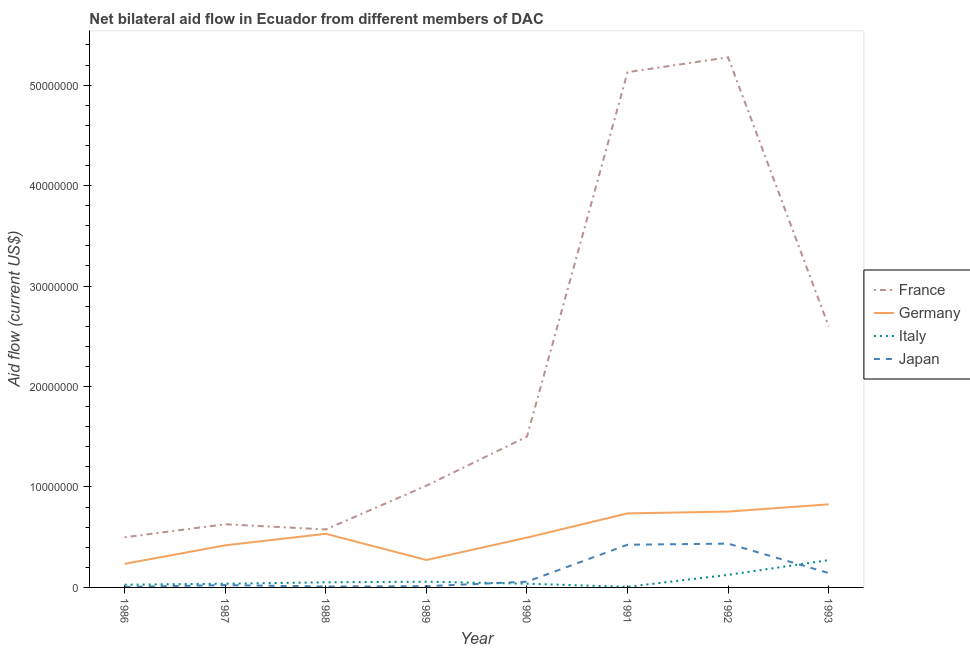How many different coloured lines are there?
Keep it short and to the point. 4. Is the number of lines equal to the number of legend labels?
Your answer should be very brief. Yes. What is the amount of aid given by italy in 1991?
Keep it short and to the point. 6.00e+04. Across all years, what is the maximum amount of aid given by japan?
Give a very brief answer. 4.36e+06. Across all years, what is the minimum amount of aid given by italy?
Provide a short and direct response. 6.00e+04. In which year was the amount of aid given by japan minimum?
Keep it short and to the point. 1986. What is the total amount of aid given by france in the graph?
Provide a succinct answer. 1.72e+08. What is the difference between the amount of aid given by japan in 1986 and that in 1989?
Keep it short and to the point. -7.00e+04. What is the difference between the amount of aid given by italy in 1992 and the amount of aid given by germany in 1988?
Make the answer very short. -4.09e+06. What is the average amount of aid given by france per year?
Your answer should be compact. 2.15e+07. In the year 1986, what is the difference between the amount of aid given by germany and amount of aid given by japan?
Offer a very short reply. 2.30e+06. In how many years, is the amount of aid given by france greater than 48000000 US$?
Provide a short and direct response. 2. What is the ratio of the amount of aid given by italy in 1989 to that in 1992?
Your answer should be compact. 0.46. Is the amount of aid given by japan in 1989 less than that in 1991?
Offer a very short reply. Yes. What is the difference between the highest and the second highest amount of aid given by france?
Give a very brief answer. 1.48e+06. What is the difference between the highest and the lowest amount of aid given by japan?
Keep it short and to the point. 4.31e+06. In how many years, is the amount of aid given by france greater than the average amount of aid given by france taken over all years?
Your answer should be compact. 3. Is the sum of the amount of aid given by italy in 1990 and 1993 greater than the maximum amount of aid given by japan across all years?
Offer a very short reply. No. Is it the case that in every year, the sum of the amount of aid given by japan and amount of aid given by germany is greater than the sum of amount of aid given by france and amount of aid given by italy?
Offer a terse response. No. Is it the case that in every year, the sum of the amount of aid given by france and amount of aid given by germany is greater than the amount of aid given by italy?
Ensure brevity in your answer.  Yes. Is the amount of aid given by japan strictly less than the amount of aid given by germany over the years?
Make the answer very short. Yes. How many lines are there?
Offer a terse response. 4. Are the values on the major ticks of Y-axis written in scientific E-notation?
Your response must be concise. No. Does the graph contain any zero values?
Ensure brevity in your answer.  No. Does the graph contain grids?
Offer a very short reply. No. Where does the legend appear in the graph?
Make the answer very short. Center right. How many legend labels are there?
Your response must be concise. 4. What is the title of the graph?
Keep it short and to the point. Net bilateral aid flow in Ecuador from different members of DAC. Does "Primary" appear as one of the legend labels in the graph?
Give a very brief answer. No. What is the label or title of the Y-axis?
Offer a very short reply. Aid flow (current US$). What is the Aid flow (current US$) in France in 1986?
Give a very brief answer. 4.99e+06. What is the Aid flow (current US$) in Germany in 1986?
Your answer should be very brief. 2.35e+06. What is the Aid flow (current US$) of France in 1987?
Offer a terse response. 6.29e+06. What is the Aid flow (current US$) of Germany in 1987?
Offer a terse response. 4.19e+06. What is the Aid flow (current US$) of France in 1988?
Offer a terse response. 5.77e+06. What is the Aid flow (current US$) of Germany in 1988?
Your answer should be very brief. 5.34e+06. What is the Aid flow (current US$) in Italy in 1988?
Provide a short and direct response. 5.10e+05. What is the Aid flow (current US$) of Japan in 1988?
Provide a succinct answer. 9.00e+04. What is the Aid flow (current US$) in France in 1989?
Offer a very short reply. 1.01e+07. What is the Aid flow (current US$) of Germany in 1989?
Ensure brevity in your answer.  2.73e+06. What is the Aid flow (current US$) in Italy in 1989?
Ensure brevity in your answer.  5.70e+05. What is the Aid flow (current US$) of Japan in 1989?
Provide a succinct answer. 1.20e+05. What is the Aid flow (current US$) of France in 1990?
Your answer should be compact. 1.50e+07. What is the Aid flow (current US$) of Germany in 1990?
Offer a terse response. 4.96e+06. What is the Aid flow (current US$) of Japan in 1990?
Your answer should be very brief. 5.70e+05. What is the Aid flow (current US$) in France in 1991?
Your answer should be very brief. 5.13e+07. What is the Aid flow (current US$) in Germany in 1991?
Your response must be concise. 7.37e+06. What is the Aid flow (current US$) in Italy in 1991?
Your response must be concise. 6.00e+04. What is the Aid flow (current US$) in Japan in 1991?
Ensure brevity in your answer.  4.25e+06. What is the Aid flow (current US$) of France in 1992?
Make the answer very short. 5.28e+07. What is the Aid flow (current US$) in Germany in 1992?
Ensure brevity in your answer.  7.55e+06. What is the Aid flow (current US$) in Italy in 1992?
Your response must be concise. 1.25e+06. What is the Aid flow (current US$) in Japan in 1992?
Your answer should be very brief. 4.36e+06. What is the Aid flow (current US$) of France in 1993?
Provide a succinct answer. 2.60e+07. What is the Aid flow (current US$) of Germany in 1993?
Ensure brevity in your answer.  8.27e+06. What is the Aid flow (current US$) of Italy in 1993?
Your answer should be very brief. 2.72e+06. What is the Aid flow (current US$) of Japan in 1993?
Give a very brief answer. 1.43e+06. Across all years, what is the maximum Aid flow (current US$) in France?
Give a very brief answer. 5.28e+07. Across all years, what is the maximum Aid flow (current US$) of Germany?
Provide a succinct answer. 8.27e+06. Across all years, what is the maximum Aid flow (current US$) of Italy?
Your answer should be very brief. 2.72e+06. Across all years, what is the maximum Aid flow (current US$) in Japan?
Your answer should be very brief. 4.36e+06. Across all years, what is the minimum Aid flow (current US$) in France?
Offer a very short reply. 4.99e+06. Across all years, what is the minimum Aid flow (current US$) in Germany?
Your response must be concise. 2.35e+06. Across all years, what is the minimum Aid flow (current US$) of Italy?
Provide a succinct answer. 6.00e+04. What is the total Aid flow (current US$) in France in the graph?
Offer a very short reply. 1.72e+08. What is the total Aid flow (current US$) of Germany in the graph?
Provide a short and direct response. 4.28e+07. What is the total Aid flow (current US$) of Italy in the graph?
Your answer should be very brief. 6.12e+06. What is the total Aid flow (current US$) of Japan in the graph?
Ensure brevity in your answer.  1.11e+07. What is the difference between the Aid flow (current US$) in France in 1986 and that in 1987?
Ensure brevity in your answer.  -1.30e+06. What is the difference between the Aid flow (current US$) of Germany in 1986 and that in 1987?
Make the answer very short. -1.84e+06. What is the difference between the Aid flow (current US$) in Italy in 1986 and that in 1987?
Make the answer very short. -1.00e+05. What is the difference between the Aid flow (current US$) of France in 1986 and that in 1988?
Ensure brevity in your answer.  -7.80e+05. What is the difference between the Aid flow (current US$) in Germany in 1986 and that in 1988?
Ensure brevity in your answer.  -2.99e+06. What is the difference between the Aid flow (current US$) of Japan in 1986 and that in 1988?
Offer a terse response. -4.00e+04. What is the difference between the Aid flow (current US$) in France in 1986 and that in 1989?
Your answer should be very brief. -5.14e+06. What is the difference between the Aid flow (current US$) in Germany in 1986 and that in 1989?
Offer a very short reply. -3.80e+05. What is the difference between the Aid flow (current US$) in Japan in 1986 and that in 1989?
Your answer should be compact. -7.00e+04. What is the difference between the Aid flow (current US$) of France in 1986 and that in 1990?
Give a very brief answer. -1.00e+07. What is the difference between the Aid flow (current US$) of Germany in 1986 and that in 1990?
Make the answer very short. -2.61e+06. What is the difference between the Aid flow (current US$) of Japan in 1986 and that in 1990?
Ensure brevity in your answer.  -5.20e+05. What is the difference between the Aid flow (current US$) of France in 1986 and that in 1991?
Your answer should be very brief. -4.63e+07. What is the difference between the Aid flow (current US$) in Germany in 1986 and that in 1991?
Keep it short and to the point. -5.02e+06. What is the difference between the Aid flow (current US$) of Italy in 1986 and that in 1991?
Give a very brief answer. 2.10e+05. What is the difference between the Aid flow (current US$) of Japan in 1986 and that in 1991?
Your answer should be compact. -4.20e+06. What is the difference between the Aid flow (current US$) in France in 1986 and that in 1992?
Your response must be concise. -4.78e+07. What is the difference between the Aid flow (current US$) of Germany in 1986 and that in 1992?
Your answer should be compact. -5.20e+06. What is the difference between the Aid flow (current US$) in Italy in 1986 and that in 1992?
Your answer should be very brief. -9.80e+05. What is the difference between the Aid flow (current US$) of Japan in 1986 and that in 1992?
Provide a succinct answer. -4.31e+06. What is the difference between the Aid flow (current US$) in France in 1986 and that in 1993?
Your answer should be very brief. -2.10e+07. What is the difference between the Aid flow (current US$) in Germany in 1986 and that in 1993?
Provide a short and direct response. -5.92e+06. What is the difference between the Aid flow (current US$) of Italy in 1986 and that in 1993?
Keep it short and to the point. -2.45e+06. What is the difference between the Aid flow (current US$) in Japan in 1986 and that in 1993?
Your answer should be very brief. -1.38e+06. What is the difference between the Aid flow (current US$) in France in 1987 and that in 1988?
Provide a succinct answer. 5.20e+05. What is the difference between the Aid flow (current US$) of Germany in 1987 and that in 1988?
Provide a succinct answer. -1.15e+06. What is the difference between the Aid flow (current US$) of Japan in 1987 and that in 1988?
Your response must be concise. 1.40e+05. What is the difference between the Aid flow (current US$) of France in 1987 and that in 1989?
Offer a very short reply. -3.84e+06. What is the difference between the Aid flow (current US$) of Germany in 1987 and that in 1989?
Provide a succinct answer. 1.46e+06. What is the difference between the Aid flow (current US$) of France in 1987 and that in 1990?
Offer a terse response. -8.72e+06. What is the difference between the Aid flow (current US$) of Germany in 1987 and that in 1990?
Your answer should be very brief. -7.70e+05. What is the difference between the Aid flow (current US$) of Italy in 1987 and that in 1990?
Your response must be concise. 0. What is the difference between the Aid flow (current US$) of Japan in 1987 and that in 1990?
Offer a very short reply. -3.40e+05. What is the difference between the Aid flow (current US$) in France in 1987 and that in 1991?
Provide a succinct answer. -4.50e+07. What is the difference between the Aid flow (current US$) in Germany in 1987 and that in 1991?
Make the answer very short. -3.18e+06. What is the difference between the Aid flow (current US$) of Italy in 1987 and that in 1991?
Provide a short and direct response. 3.10e+05. What is the difference between the Aid flow (current US$) in Japan in 1987 and that in 1991?
Give a very brief answer. -4.02e+06. What is the difference between the Aid flow (current US$) in France in 1987 and that in 1992?
Provide a short and direct response. -4.65e+07. What is the difference between the Aid flow (current US$) in Germany in 1987 and that in 1992?
Provide a short and direct response. -3.36e+06. What is the difference between the Aid flow (current US$) of Italy in 1987 and that in 1992?
Give a very brief answer. -8.80e+05. What is the difference between the Aid flow (current US$) in Japan in 1987 and that in 1992?
Your response must be concise. -4.13e+06. What is the difference between the Aid flow (current US$) in France in 1987 and that in 1993?
Offer a very short reply. -1.97e+07. What is the difference between the Aid flow (current US$) in Germany in 1987 and that in 1993?
Your answer should be very brief. -4.08e+06. What is the difference between the Aid flow (current US$) in Italy in 1987 and that in 1993?
Your answer should be very brief. -2.35e+06. What is the difference between the Aid flow (current US$) of Japan in 1987 and that in 1993?
Give a very brief answer. -1.20e+06. What is the difference between the Aid flow (current US$) in France in 1988 and that in 1989?
Your answer should be very brief. -4.36e+06. What is the difference between the Aid flow (current US$) of Germany in 1988 and that in 1989?
Offer a terse response. 2.61e+06. What is the difference between the Aid flow (current US$) in France in 1988 and that in 1990?
Your answer should be compact. -9.24e+06. What is the difference between the Aid flow (current US$) in Italy in 1988 and that in 1990?
Your answer should be compact. 1.40e+05. What is the difference between the Aid flow (current US$) in Japan in 1988 and that in 1990?
Offer a very short reply. -4.80e+05. What is the difference between the Aid flow (current US$) of France in 1988 and that in 1991?
Offer a very short reply. -4.55e+07. What is the difference between the Aid flow (current US$) in Germany in 1988 and that in 1991?
Make the answer very short. -2.03e+06. What is the difference between the Aid flow (current US$) of Japan in 1988 and that in 1991?
Make the answer very short. -4.16e+06. What is the difference between the Aid flow (current US$) of France in 1988 and that in 1992?
Your answer should be compact. -4.70e+07. What is the difference between the Aid flow (current US$) of Germany in 1988 and that in 1992?
Ensure brevity in your answer.  -2.21e+06. What is the difference between the Aid flow (current US$) in Italy in 1988 and that in 1992?
Make the answer very short. -7.40e+05. What is the difference between the Aid flow (current US$) in Japan in 1988 and that in 1992?
Offer a very short reply. -4.27e+06. What is the difference between the Aid flow (current US$) of France in 1988 and that in 1993?
Provide a succinct answer. -2.02e+07. What is the difference between the Aid flow (current US$) of Germany in 1988 and that in 1993?
Provide a succinct answer. -2.93e+06. What is the difference between the Aid flow (current US$) of Italy in 1988 and that in 1993?
Offer a very short reply. -2.21e+06. What is the difference between the Aid flow (current US$) of Japan in 1988 and that in 1993?
Give a very brief answer. -1.34e+06. What is the difference between the Aid flow (current US$) in France in 1989 and that in 1990?
Your answer should be compact. -4.88e+06. What is the difference between the Aid flow (current US$) of Germany in 1989 and that in 1990?
Offer a terse response. -2.23e+06. What is the difference between the Aid flow (current US$) of Italy in 1989 and that in 1990?
Your answer should be compact. 2.00e+05. What is the difference between the Aid flow (current US$) in Japan in 1989 and that in 1990?
Your response must be concise. -4.50e+05. What is the difference between the Aid flow (current US$) of France in 1989 and that in 1991?
Give a very brief answer. -4.12e+07. What is the difference between the Aid flow (current US$) in Germany in 1989 and that in 1991?
Offer a very short reply. -4.64e+06. What is the difference between the Aid flow (current US$) of Italy in 1989 and that in 1991?
Offer a terse response. 5.10e+05. What is the difference between the Aid flow (current US$) of Japan in 1989 and that in 1991?
Give a very brief answer. -4.13e+06. What is the difference between the Aid flow (current US$) of France in 1989 and that in 1992?
Your response must be concise. -4.26e+07. What is the difference between the Aid flow (current US$) in Germany in 1989 and that in 1992?
Offer a terse response. -4.82e+06. What is the difference between the Aid flow (current US$) of Italy in 1989 and that in 1992?
Make the answer very short. -6.80e+05. What is the difference between the Aid flow (current US$) in Japan in 1989 and that in 1992?
Your response must be concise. -4.24e+06. What is the difference between the Aid flow (current US$) in France in 1989 and that in 1993?
Offer a terse response. -1.59e+07. What is the difference between the Aid flow (current US$) in Germany in 1989 and that in 1993?
Provide a succinct answer. -5.54e+06. What is the difference between the Aid flow (current US$) of Italy in 1989 and that in 1993?
Keep it short and to the point. -2.15e+06. What is the difference between the Aid flow (current US$) of Japan in 1989 and that in 1993?
Give a very brief answer. -1.31e+06. What is the difference between the Aid flow (current US$) in France in 1990 and that in 1991?
Keep it short and to the point. -3.63e+07. What is the difference between the Aid flow (current US$) in Germany in 1990 and that in 1991?
Offer a terse response. -2.41e+06. What is the difference between the Aid flow (current US$) of Japan in 1990 and that in 1991?
Your response must be concise. -3.68e+06. What is the difference between the Aid flow (current US$) in France in 1990 and that in 1992?
Provide a succinct answer. -3.78e+07. What is the difference between the Aid flow (current US$) in Germany in 1990 and that in 1992?
Keep it short and to the point. -2.59e+06. What is the difference between the Aid flow (current US$) of Italy in 1990 and that in 1992?
Offer a terse response. -8.80e+05. What is the difference between the Aid flow (current US$) of Japan in 1990 and that in 1992?
Offer a very short reply. -3.79e+06. What is the difference between the Aid flow (current US$) in France in 1990 and that in 1993?
Give a very brief answer. -1.10e+07. What is the difference between the Aid flow (current US$) of Germany in 1990 and that in 1993?
Provide a succinct answer. -3.31e+06. What is the difference between the Aid flow (current US$) of Italy in 1990 and that in 1993?
Ensure brevity in your answer.  -2.35e+06. What is the difference between the Aid flow (current US$) of Japan in 1990 and that in 1993?
Your answer should be very brief. -8.60e+05. What is the difference between the Aid flow (current US$) in France in 1991 and that in 1992?
Offer a very short reply. -1.48e+06. What is the difference between the Aid flow (current US$) of Italy in 1991 and that in 1992?
Your answer should be very brief. -1.19e+06. What is the difference between the Aid flow (current US$) of Japan in 1991 and that in 1992?
Offer a very short reply. -1.10e+05. What is the difference between the Aid flow (current US$) in France in 1991 and that in 1993?
Give a very brief answer. 2.53e+07. What is the difference between the Aid flow (current US$) in Germany in 1991 and that in 1993?
Give a very brief answer. -9.00e+05. What is the difference between the Aid flow (current US$) in Italy in 1991 and that in 1993?
Make the answer very short. -2.66e+06. What is the difference between the Aid flow (current US$) in Japan in 1991 and that in 1993?
Provide a short and direct response. 2.82e+06. What is the difference between the Aid flow (current US$) in France in 1992 and that in 1993?
Your answer should be very brief. 2.68e+07. What is the difference between the Aid flow (current US$) in Germany in 1992 and that in 1993?
Your answer should be compact. -7.20e+05. What is the difference between the Aid flow (current US$) of Italy in 1992 and that in 1993?
Offer a very short reply. -1.47e+06. What is the difference between the Aid flow (current US$) in Japan in 1992 and that in 1993?
Provide a succinct answer. 2.93e+06. What is the difference between the Aid flow (current US$) in France in 1986 and the Aid flow (current US$) in Germany in 1987?
Offer a terse response. 8.00e+05. What is the difference between the Aid flow (current US$) of France in 1986 and the Aid flow (current US$) of Italy in 1987?
Your answer should be very brief. 4.62e+06. What is the difference between the Aid flow (current US$) of France in 1986 and the Aid flow (current US$) of Japan in 1987?
Ensure brevity in your answer.  4.76e+06. What is the difference between the Aid flow (current US$) of Germany in 1986 and the Aid flow (current US$) of Italy in 1987?
Give a very brief answer. 1.98e+06. What is the difference between the Aid flow (current US$) in Germany in 1986 and the Aid flow (current US$) in Japan in 1987?
Give a very brief answer. 2.12e+06. What is the difference between the Aid flow (current US$) of France in 1986 and the Aid flow (current US$) of Germany in 1988?
Offer a very short reply. -3.50e+05. What is the difference between the Aid flow (current US$) of France in 1986 and the Aid flow (current US$) of Italy in 1988?
Keep it short and to the point. 4.48e+06. What is the difference between the Aid flow (current US$) of France in 1986 and the Aid flow (current US$) of Japan in 1988?
Keep it short and to the point. 4.90e+06. What is the difference between the Aid flow (current US$) of Germany in 1986 and the Aid flow (current US$) of Italy in 1988?
Offer a terse response. 1.84e+06. What is the difference between the Aid flow (current US$) in Germany in 1986 and the Aid flow (current US$) in Japan in 1988?
Your response must be concise. 2.26e+06. What is the difference between the Aid flow (current US$) in France in 1986 and the Aid flow (current US$) in Germany in 1989?
Offer a terse response. 2.26e+06. What is the difference between the Aid flow (current US$) in France in 1986 and the Aid flow (current US$) in Italy in 1989?
Provide a short and direct response. 4.42e+06. What is the difference between the Aid flow (current US$) in France in 1986 and the Aid flow (current US$) in Japan in 1989?
Your answer should be compact. 4.87e+06. What is the difference between the Aid flow (current US$) in Germany in 1986 and the Aid flow (current US$) in Italy in 1989?
Give a very brief answer. 1.78e+06. What is the difference between the Aid flow (current US$) in Germany in 1986 and the Aid flow (current US$) in Japan in 1989?
Provide a succinct answer. 2.23e+06. What is the difference between the Aid flow (current US$) in Italy in 1986 and the Aid flow (current US$) in Japan in 1989?
Provide a short and direct response. 1.50e+05. What is the difference between the Aid flow (current US$) in France in 1986 and the Aid flow (current US$) in Italy in 1990?
Provide a short and direct response. 4.62e+06. What is the difference between the Aid flow (current US$) of France in 1986 and the Aid flow (current US$) of Japan in 1990?
Offer a very short reply. 4.42e+06. What is the difference between the Aid flow (current US$) in Germany in 1986 and the Aid flow (current US$) in Italy in 1990?
Offer a terse response. 1.98e+06. What is the difference between the Aid flow (current US$) in Germany in 1986 and the Aid flow (current US$) in Japan in 1990?
Provide a short and direct response. 1.78e+06. What is the difference between the Aid flow (current US$) in Italy in 1986 and the Aid flow (current US$) in Japan in 1990?
Offer a terse response. -3.00e+05. What is the difference between the Aid flow (current US$) of France in 1986 and the Aid flow (current US$) of Germany in 1991?
Your response must be concise. -2.38e+06. What is the difference between the Aid flow (current US$) of France in 1986 and the Aid flow (current US$) of Italy in 1991?
Provide a succinct answer. 4.93e+06. What is the difference between the Aid flow (current US$) of France in 1986 and the Aid flow (current US$) of Japan in 1991?
Provide a succinct answer. 7.40e+05. What is the difference between the Aid flow (current US$) of Germany in 1986 and the Aid flow (current US$) of Italy in 1991?
Keep it short and to the point. 2.29e+06. What is the difference between the Aid flow (current US$) in Germany in 1986 and the Aid flow (current US$) in Japan in 1991?
Provide a short and direct response. -1.90e+06. What is the difference between the Aid flow (current US$) in Italy in 1986 and the Aid flow (current US$) in Japan in 1991?
Your answer should be compact. -3.98e+06. What is the difference between the Aid flow (current US$) in France in 1986 and the Aid flow (current US$) in Germany in 1992?
Keep it short and to the point. -2.56e+06. What is the difference between the Aid flow (current US$) of France in 1986 and the Aid flow (current US$) of Italy in 1992?
Provide a short and direct response. 3.74e+06. What is the difference between the Aid flow (current US$) in France in 1986 and the Aid flow (current US$) in Japan in 1992?
Make the answer very short. 6.30e+05. What is the difference between the Aid flow (current US$) in Germany in 1986 and the Aid flow (current US$) in Italy in 1992?
Give a very brief answer. 1.10e+06. What is the difference between the Aid flow (current US$) of Germany in 1986 and the Aid flow (current US$) of Japan in 1992?
Ensure brevity in your answer.  -2.01e+06. What is the difference between the Aid flow (current US$) of Italy in 1986 and the Aid flow (current US$) of Japan in 1992?
Your answer should be compact. -4.09e+06. What is the difference between the Aid flow (current US$) in France in 1986 and the Aid flow (current US$) in Germany in 1993?
Make the answer very short. -3.28e+06. What is the difference between the Aid flow (current US$) in France in 1986 and the Aid flow (current US$) in Italy in 1993?
Your response must be concise. 2.27e+06. What is the difference between the Aid flow (current US$) in France in 1986 and the Aid flow (current US$) in Japan in 1993?
Your answer should be compact. 3.56e+06. What is the difference between the Aid flow (current US$) in Germany in 1986 and the Aid flow (current US$) in Italy in 1993?
Offer a very short reply. -3.70e+05. What is the difference between the Aid flow (current US$) of Germany in 1986 and the Aid flow (current US$) of Japan in 1993?
Your response must be concise. 9.20e+05. What is the difference between the Aid flow (current US$) of Italy in 1986 and the Aid flow (current US$) of Japan in 1993?
Provide a short and direct response. -1.16e+06. What is the difference between the Aid flow (current US$) in France in 1987 and the Aid flow (current US$) in Germany in 1988?
Make the answer very short. 9.50e+05. What is the difference between the Aid flow (current US$) in France in 1987 and the Aid flow (current US$) in Italy in 1988?
Offer a terse response. 5.78e+06. What is the difference between the Aid flow (current US$) of France in 1987 and the Aid flow (current US$) of Japan in 1988?
Keep it short and to the point. 6.20e+06. What is the difference between the Aid flow (current US$) of Germany in 1987 and the Aid flow (current US$) of Italy in 1988?
Provide a succinct answer. 3.68e+06. What is the difference between the Aid flow (current US$) in Germany in 1987 and the Aid flow (current US$) in Japan in 1988?
Offer a very short reply. 4.10e+06. What is the difference between the Aid flow (current US$) of Italy in 1987 and the Aid flow (current US$) of Japan in 1988?
Your answer should be very brief. 2.80e+05. What is the difference between the Aid flow (current US$) of France in 1987 and the Aid flow (current US$) of Germany in 1989?
Offer a terse response. 3.56e+06. What is the difference between the Aid flow (current US$) of France in 1987 and the Aid flow (current US$) of Italy in 1989?
Provide a short and direct response. 5.72e+06. What is the difference between the Aid flow (current US$) of France in 1987 and the Aid flow (current US$) of Japan in 1989?
Offer a very short reply. 6.17e+06. What is the difference between the Aid flow (current US$) of Germany in 1987 and the Aid flow (current US$) of Italy in 1989?
Make the answer very short. 3.62e+06. What is the difference between the Aid flow (current US$) of Germany in 1987 and the Aid flow (current US$) of Japan in 1989?
Ensure brevity in your answer.  4.07e+06. What is the difference between the Aid flow (current US$) of France in 1987 and the Aid flow (current US$) of Germany in 1990?
Keep it short and to the point. 1.33e+06. What is the difference between the Aid flow (current US$) of France in 1987 and the Aid flow (current US$) of Italy in 1990?
Offer a very short reply. 5.92e+06. What is the difference between the Aid flow (current US$) of France in 1987 and the Aid flow (current US$) of Japan in 1990?
Give a very brief answer. 5.72e+06. What is the difference between the Aid flow (current US$) of Germany in 1987 and the Aid flow (current US$) of Italy in 1990?
Provide a short and direct response. 3.82e+06. What is the difference between the Aid flow (current US$) in Germany in 1987 and the Aid flow (current US$) in Japan in 1990?
Your response must be concise. 3.62e+06. What is the difference between the Aid flow (current US$) in Italy in 1987 and the Aid flow (current US$) in Japan in 1990?
Your answer should be compact. -2.00e+05. What is the difference between the Aid flow (current US$) in France in 1987 and the Aid flow (current US$) in Germany in 1991?
Make the answer very short. -1.08e+06. What is the difference between the Aid flow (current US$) of France in 1987 and the Aid flow (current US$) of Italy in 1991?
Offer a terse response. 6.23e+06. What is the difference between the Aid flow (current US$) of France in 1987 and the Aid flow (current US$) of Japan in 1991?
Offer a terse response. 2.04e+06. What is the difference between the Aid flow (current US$) in Germany in 1987 and the Aid flow (current US$) in Italy in 1991?
Provide a succinct answer. 4.13e+06. What is the difference between the Aid flow (current US$) of Germany in 1987 and the Aid flow (current US$) of Japan in 1991?
Keep it short and to the point. -6.00e+04. What is the difference between the Aid flow (current US$) of Italy in 1987 and the Aid flow (current US$) of Japan in 1991?
Your answer should be very brief. -3.88e+06. What is the difference between the Aid flow (current US$) in France in 1987 and the Aid flow (current US$) in Germany in 1992?
Give a very brief answer. -1.26e+06. What is the difference between the Aid flow (current US$) in France in 1987 and the Aid flow (current US$) in Italy in 1992?
Offer a terse response. 5.04e+06. What is the difference between the Aid flow (current US$) of France in 1987 and the Aid flow (current US$) of Japan in 1992?
Ensure brevity in your answer.  1.93e+06. What is the difference between the Aid flow (current US$) in Germany in 1987 and the Aid flow (current US$) in Italy in 1992?
Ensure brevity in your answer.  2.94e+06. What is the difference between the Aid flow (current US$) in Germany in 1987 and the Aid flow (current US$) in Japan in 1992?
Your response must be concise. -1.70e+05. What is the difference between the Aid flow (current US$) in Italy in 1987 and the Aid flow (current US$) in Japan in 1992?
Make the answer very short. -3.99e+06. What is the difference between the Aid flow (current US$) in France in 1987 and the Aid flow (current US$) in Germany in 1993?
Offer a very short reply. -1.98e+06. What is the difference between the Aid flow (current US$) of France in 1987 and the Aid flow (current US$) of Italy in 1993?
Your response must be concise. 3.57e+06. What is the difference between the Aid flow (current US$) of France in 1987 and the Aid flow (current US$) of Japan in 1993?
Your answer should be very brief. 4.86e+06. What is the difference between the Aid flow (current US$) of Germany in 1987 and the Aid flow (current US$) of Italy in 1993?
Provide a succinct answer. 1.47e+06. What is the difference between the Aid flow (current US$) in Germany in 1987 and the Aid flow (current US$) in Japan in 1993?
Offer a very short reply. 2.76e+06. What is the difference between the Aid flow (current US$) of Italy in 1987 and the Aid flow (current US$) of Japan in 1993?
Ensure brevity in your answer.  -1.06e+06. What is the difference between the Aid flow (current US$) in France in 1988 and the Aid flow (current US$) in Germany in 1989?
Keep it short and to the point. 3.04e+06. What is the difference between the Aid flow (current US$) in France in 1988 and the Aid flow (current US$) in Italy in 1989?
Ensure brevity in your answer.  5.20e+06. What is the difference between the Aid flow (current US$) in France in 1988 and the Aid flow (current US$) in Japan in 1989?
Offer a very short reply. 5.65e+06. What is the difference between the Aid flow (current US$) of Germany in 1988 and the Aid flow (current US$) of Italy in 1989?
Your answer should be compact. 4.77e+06. What is the difference between the Aid flow (current US$) in Germany in 1988 and the Aid flow (current US$) in Japan in 1989?
Your response must be concise. 5.22e+06. What is the difference between the Aid flow (current US$) in Italy in 1988 and the Aid flow (current US$) in Japan in 1989?
Make the answer very short. 3.90e+05. What is the difference between the Aid flow (current US$) of France in 1988 and the Aid flow (current US$) of Germany in 1990?
Keep it short and to the point. 8.10e+05. What is the difference between the Aid flow (current US$) in France in 1988 and the Aid flow (current US$) in Italy in 1990?
Provide a succinct answer. 5.40e+06. What is the difference between the Aid flow (current US$) of France in 1988 and the Aid flow (current US$) of Japan in 1990?
Make the answer very short. 5.20e+06. What is the difference between the Aid flow (current US$) of Germany in 1988 and the Aid flow (current US$) of Italy in 1990?
Offer a terse response. 4.97e+06. What is the difference between the Aid flow (current US$) of Germany in 1988 and the Aid flow (current US$) of Japan in 1990?
Ensure brevity in your answer.  4.77e+06. What is the difference between the Aid flow (current US$) in France in 1988 and the Aid flow (current US$) in Germany in 1991?
Make the answer very short. -1.60e+06. What is the difference between the Aid flow (current US$) of France in 1988 and the Aid flow (current US$) of Italy in 1991?
Keep it short and to the point. 5.71e+06. What is the difference between the Aid flow (current US$) in France in 1988 and the Aid flow (current US$) in Japan in 1991?
Give a very brief answer. 1.52e+06. What is the difference between the Aid flow (current US$) of Germany in 1988 and the Aid flow (current US$) of Italy in 1991?
Provide a succinct answer. 5.28e+06. What is the difference between the Aid flow (current US$) of Germany in 1988 and the Aid flow (current US$) of Japan in 1991?
Provide a short and direct response. 1.09e+06. What is the difference between the Aid flow (current US$) in Italy in 1988 and the Aid flow (current US$) in Japan in 1991?
Provide a succinct answer. -3.74e+06. What is the difference between the Aid flow (current US$) of France in 1988 and the Aid flow (current US$) of Germany in 1992?
Provide a succinct answer. -1.78e+06. What is the difference between the Aid flow (current US$) of France in 1988 and the Aid flow (current US$) of Italy in 1992?
Ensure brevity in your answer.  4.52e+06. What is the difference between the Aid flow (current US$) in France in 1988 and the Aid flow (current US$) in Japan in 1992?
Provide a succinct answer. 1.41e+06. What is the difference between the Aid flow (current US$) of Germany in 1988 and the Aid flow (current US$) of Italy in 1992?
Make the answer very short. 4.09e+06. What is the difference between the Aid flow (current US$) in Germany in 1988 and the Aid flow (current US$) in Japan in 1992?
Give a very brief answer. 9.80e+05. What is the difference between the Aid flow (current US$) in Italy in 1988 and the Aid flow (current US$) in Japan in 1992?
Your answer should be very brief. -3.85e+06. What is the difference between the Aid flow (current US$) in France in 1988 and the Aid flow (current US$) in Germany in 1993?
Ensure brevity in your answer.  -2.50e+06. What is the difference between the Aid flow (current US$) of France in 1988 and the Aid flow (current US$) of Italy in 1993?
Your answer should be very brief. 3.05e+06. What is the difference between the Aid flow (current US$) in France in 1988 and the Aid flow (current US$) in Japan in 1993?
Ensure brevity in your answer.  4.34e+06. What is the difference between the Aid flow (current US$) in Germany in 1988 and the Aid flow (current US$) in Italy in 1993?
Ensure brevity in your answer.  2.62e+06. What is the difference between the Aid flow (current US$) in Germany in 1988 and the Aid flow (current US$) in Japan in 1993?
Give a very brief answer. 3.91e+06. What is the difference between the Aid flow (current US$) in Italy in 1988 and the Aid flow (current US$) in Japan in 1993?
Provide a short and direct response. -9.20e+05. What is the difference between the Aid flow (current US$) of France in 1989 and the Aid flow (current US$) of Germany in 1990?
Your answer should be very brief. 5.17e+06. What is the difference between the Aid flow (current US$) of France in 1989 and the Aid flow (current US$) of Italy in 1990?
Ensure brevity in your answer.  9.76e+06. What is the difference between the Aid flow (current US$) in France in 1989 and the Aid flow (current US$) in Japan in 1990?
Offer a terse response. 9.56e+06. What is the difference between the Aid flow (current US$) in Germany in 1989 and the Aid flow (current US$) in Italy in 1990?
Your response must be concise. 2.36e+06. What is the difference between the Aid flow (current US$) of Germany in 1989 and the Aid flow (current US$) of Japan in 1990?
Provide a succinct answer. 2.16e+06. What is the difference between the Aid flow (current US$) of Italy in 1989 and the Aid flow (current US$) of Japan in 1990?
Keep it short and to the point. 0. What is the difference between the Aid flow (current US$) in France in 1989 and the Aid flow (current US$) in Germany in 1991?
Your response must be concise. 2.76e+06. What is the difference between the Aid flow (current US$) in France in 1989 and the Aid flow (current US$) in Italy in 1991?
Provide a succinct answer. 1.01e+07. What is the difference between the Aid flow (current US$) of France in 1989 and the Aid flow (current US$) of Japan in 1991?
Ensure brevity in your answer.  5.88e+06. What is the difference between the Aid flow (current US$) of Germany in 1989 and the Aid flow (current US$) of Italy in 1991?
Make the answer very short. 2.67e+06. What is the difference between the Aid flow (current US$) of Germany in 1989 and the Aid flow (current US$) of Japan in 1991?
Offer a very short reply. -1.52e+06. What is the difference between the Aid flow (current US$) in Italy in 1989 and the Aid flow (current US$) in Japan in 1991?
Provide a succinct answer. -3.68e+06. What is the difference between the Aid flow (current US$) in France in 1989 and the Aid flow (current US$) in Germany in 1992?
Offer a terse response. 2.58e+06. What is the difference between the Aid flow (current US$) of France in 1989 and the Aid flow (current US$) of Italy in 1992?
Provide a short and direct response. 8.88e+06. What is the difference between the Aid flow (current US$) of France in 1989 and the Aid flow (current US$) of Japan in 1992?
Offer a terse response. 5.77e+06. What is the difference between the Aid flow (current US$) in Germany in 1989 and the Aid flow (current US$) in Italy in 1992?
Ensure brevity in your answer.  1.48e+06. What is the difference between the Aid flow (current US$) in Germany in 1989 and the Aid flow (current US$) in Japan in 1992?
Your response must be concise. -1.63e+06. What is the difference between the Aid flow (current US$) of Italy in 1989 and the Aid flow (current US$) of Japan in 1992?
Offer a very short reply. -3.79e+06. What is the difference between the Aid flow (current US$) in France in 1989 and the Aid flow (current US$) in Germany in 1993?
Provide a short and direct response. 1.86e+06. What is the difference between the Aid flow (current US$) in France in 1989 and the Aid flow (current US$) in Italy in 1993?
Offer a very short reply. 7.41e+06. What is the difference between the Aid flow (current US$) in France in 1989 and the Aid flow (current US$) in Japan in 1993?
Provide a short and direct response. 8.70e+06. What is the difference between the Aid flow (current US$) in Germany in 1989 and the Aid flow (current US$) in Japan in 1993?
Your response must be concise. 1.30e+06. What is the difference between the Aid flow (current US$) in Italy in 1989 and the Aid flow (current US$) in Japan in 1993?
Make the answer very short. -8.60e+05. What is the difference between the Aid flow (current US$) of France in 1990 and the Aid flow (current US$) of Germany in 1991?
Make the answer very short. 7.64e+06. What is the difference between the Aid flow (current US$) of France in 1990 and the Aid flow (current US$) of Italy in 1991?
Ensure brevity in your answer.  1.50e+07. What is the difference between the Aid flow (current US$) of France in 1990 and the Aid flow (current US$) of Japan in 1991?
Give a very brief answer. 1.08e+07. What is the difference between the Aid flow (current US$) of Germany in 1990 and the Aid flow (current US$) of Italy in 1991?
Provide a succinct answer. 4.90e+06. What is the difference between the Aid flow (current US$) in Germany in 1990 and the Aid flow (current US$) in Japan in 1991?
Provide a succinct answer. 7.10e+05. What is the difference between the Aid flow (current US$) of Italy in 1990 and the Aid flow (current US$) of Japan in 1991?
Provide a succinct answer. -3.88e+06. What is the difference between the Aid flow (current US$) in France in 1990 and the Aid flow (current US$) in Germany in 1992?
Give a very brief answer. 7.46e+06. What is the difference between the Aid flow (current US$) in France in 1990 and the Aid flow (current US$) in Italy in 1992?
Your answer should be very brief. 1.38e+07. What is the difference between the Aid flow (current US$) in France in 1990 and the Aid flow (current US$) in Japan in 1992?
Offer a terse response. 1.06e+07. What is the difference between the Aid flow (current US$) of Germany in 1990 and the Aid flow (current US$) of Italy in 1992?
Your response must be concise. 3.71e+06. What is the difference between the Aid flow (current US$) of Germany in 1990 and the Aid flow (current US$) of Japan in 1992?
Your response must be concise. 6.00e+05. What is the difference between the Aid flow (current US$) in Italy in 1990 and the Aid flow (current US$) in Japan in 1992?
Make the answer very short. -3.99e+06. What is the difference between the Aid flow (current US$) of France in 1990 and the Aid flow (current US$) of Germany in 1993?
Offer a very short reply. 6.74e+06. What is the difference between the Aid flow (current US$) of France in 1990 and the Aid flow (current US$) of Italy in 1993?
Offer a very short reply. 1.23e+07. What is the difference between the Aid flow (current US$) in France in 1990 and the Aid flow (current US$) in Japan in 1993?
Offer a terse response. 1.36e+07. What is the difference between the Aid flow (current US$) of Germany in 1990 and the Aid flow (current US$) of Italy in 1993?
Ensure brevity in your answer.  2.24e+06. What is the difference between the Aid flow (current US$) of Germany in 1990 and the Aid flow (current US$) of Japan in 1993?
Offer a terse response. 3.53e+06. What is the difference between the Aid flow (current US$) in Italy in 1990 and the Aid flow (current US$) in Japan in 1993?
Ensure brevity in your answer.  -1.06e+06. What is the difference between the Aid flow (current US$) of France in 1991 and the Aid flow (current US$) of Germany in 1992?
Your response must be concise. 4.37e+07. What is the difference between the Aid flow (current US$) in France in 1991 and the Aid flow (current US$) in Italy in 1992?
Ensure brevity in your answer.  5.00e+07. What is the difference between the Aid flow (current US$) of France in 1991 and the Aid flow (current US$) of Japan in 1992?
Ensure brevity in your answer.  4.69e+07. What is the difference between the Aid flow (current US$) in Germany in 1991 and the Aid flow (current US$) in Italy in 1992?
Keep it short and to the point. 6.12e+06. What is the difference between the Aid flow (current US$) in Germany in 1991 and the Aid flow (current US$) in Japan in 1992?
Your answer should be very brief. 3.01e+06. What is the difference between the Aid flow (current US$) of Italy in 1991 and the Aid flow (current US$) of Japan in 1992?
Your answer should be compact. -4.30e+06. What is the difference between the Aid flow (current US$) of France in 1991 and the Aid flow (current US$) of Germany in 1993?
Ensure brevity in your answer.  4.30e+07. What is the difference between the Aid flow (current US$) in France in 1991 and the Aid flow (current US$) in Italy in 1993?
Make the answer very short. 4.86e+07. What is the difference between the Aid flow (current US$) in France in 1991 and the Aid flow (current US$) in Japan in 1993?
Offer a very short reply. 4.99e+07. What is the difference between the Aid flow (current US$) of Germany in 1991 and the Aid flow (current US$) of Italy in 1993?
Your response must be concise. 4.65e+06. What is the difference between the Aid flow (current US$) in Germany in 1991 and the Aid flow (current US$) in Japan in 1993?
Your answer should be very brief. 5.94e+06. What is the difference between the Aid flow (current US$) of Italy in 1991 and the Aid flow (current US$) of Japan in 1993?
Your answer should be very brief. -1.37e+06. What is the difference between the Aid flow (current US$) of France in 1992 and the Aid flow (current US$) of Germany in 1993?
Give a very brief answer. 4.45e+07. What is the difference between the Aid flow (current US$) of France in 1992 and the Aid flow (current US$) of Italy in 1993?
Offer a terse response. 5.00e+07. What is the difference between the Aid flow (current US$) in France in 1992 and the Aid flow (current US$) in Japan in 1993?
Offer a terse response. 5.13e+07. What is the difference between the Aid flow (current US$) in Germany in 1992 and the Aid flow (current US$) in Italy in 1993?
Ensure brevity in your answer.  4.83e+06. What is the difference between the Aid flow (current US$) of Germany in 1992 and the Aid flow (current US$) of Japan in 1993?
Provide a short and direct response. 6.12e+06. What is the difference between the Aid flow (current US$) in Italy in 1992 and the Aid flow (current US$) in Japan in 1993?
Your answer should be very brief. -1.80e+05. What is the average Aid flow (current US$) of France per year?
Provide a short and direct response. 2.15e+07. What is the average Aid flow (current US$) in Germany per year?
Your answer should be compact. 5.34e+06. What is the average Aid flow (current US$) in Italy per year?
Offer a very short reply. 7.65e+05. What is the average Aid flow (current US$) in Japan per year?
Ensure brevity in your answer.  1.39e+06. In the year 1986, what is the difference between the Aid flow (current US$) of France and Aid flow (current US$) of Germany?
Your answer should be very brief. 2.64e+06. In the year 1986, what is the difference between the Aid flow (current US$) of France and Aid flow (current US$) of Italy?
Give a very brief answer. 4.72e+06. In the year 1986, what is the difference between the Aid flow (current US$) in France and Aid flow (current US$) in Japan?
Your answer should be compact. 4.94e+06. In the year 1986, what is the difference between the Aid flow (current US$) of Germany and Aid flow (current US$) of Italy?
Provide a short and direct response. 2.08e+06. In the year 1986, what is the difference between the Aid flow (current US$) in Germany and Aid flow (current US$) in Japan?
Provide a short and direct response. 2.30e+06. In the year 1987, what is the difference between the Aid flow (current US$) in France and Aid flow (current US$) in Germany?
Provide a succinct answer. 2.10e+06. In the year 1987, what is the difference between the Aid flow (current US$) of France and Aid flow (current US$) of Italy?
Keep it short and to the point. 5.92e+06. In the year 1987, what is the difference between the Aid flow (current US$) in France and Aid flow (current US$) in Japan?
Ensure brevity in your answer.  6.06e+06. In the year 1987, what is the difference between the Aid flow (current US$) of Germany and Aid flow (current US$) of Italy?
Your response must be concise. 3.82e+06. In the year 1987, what is the difference between the Aid flow (current US$) of Germany and Aid flow (current US$) of Japan?
Make the answer very short. 3.96e+06. In the year 1988, what is the difference between the Aid flow (current US$) of France and Aid flow (current US$) of Italy?
Offer a very short reply. 5.26e+06. In the year 1988, what is the difference between the Aid flow (current US$) in France and Aid flow (current US$) in Japan?
Your answer should be compact. 5.68e+06. In the year 1988, what is the difference between the Aid flow (current US$) of Germany and Aid flow (current US$) of Italy?
Offer a terse response. 4.83e+06. In the year 1988, what is the difference between the Aid flow (current US$) of Germany and Aid flow (current US$) of Japan?
Offer a very short reply. 5.25e+06. In the year 1989, what is the difference between the Aid flow (current US$) of France and Aid flow (current US$) of Germany?
Provide a short and direct response. 7.40e+06. In the year 1989, what is the difference between the Aid flow (current US$) in France and Aid flow (current US$) in Italy?
Offer a very short reply. 9.56e+06. In the year 1989, what is the difference between the Aid flow (current US$) in France and Aid flow (current US$) in Japan?
Your answer should be compact. 1.00e+07. In the year 1989, what is the difference between the Aid flow (current US$) in Germany and Aid flow (current US$) in Italy?
Provide a short and direct response. 2.16e+06. In the year 1989, what is the difference between the Aid flow (current US$) in Germany and Aid flow (current US$) in Japan?
Provide a short and direct response. 2.61e+06. In the year 1990, what is the difference between the Aid flow (current US$) of France and Aid flow (current US$) of Germany?
Provide a short and direct response. 1.00e+07. In the year 1990, what is the difference between the Aid flow (current US$) in France and Aid flow (current US$) in Italy?
Offer a very short reply. 1.46e+07. In the year 1990, what is the difference between the Aid flow (current US$) of France and Aid flow (current US$) of Japan?
Offer a very short reply. 1.44e+07. In the year 1990, what is the difference between the Aid flow (current US$) of Germany and Aid flow (current US$) of Italy?
Ensure brevity in your answer.  4.59e+06. In the year 1990, what is the difference between the Aid flow (current US$) in Germany and Aid flow (current US$) in Japan?
Provide a short and direct response. 4.39e+06. In the year 1991, what is the difference between the Aid flow (current US$) of France and Aid flow (current US$) of Germany?
Your answer should be very brief. 4.39e+07. In the year 1991, what is the difference between the Aid flow (current US$) in France and Aid flow (current US$) in Italy?
Ensure brevity in your answer.  5.12e+07. In the year 1991, what is the difference between the Aid flow (current US$) of France and Aid flow (current US$) of Japan?
Offer a terse response. 4.70e+07. In the year 1991, what is the difference between the Aid flow (current US$) in Germany and Aid flow (current US$) in Italy?
Keep it short and to the point. 7.31e+06. In the year 1991, what is the difference between the Aid flow (current US$) in Germany and Aid flow (current US$) in Japan?
Offer a terse response. 3.12e+06. In the year 1991, what is the difference between the Aid flow (current US$) of Italy and Aid flow (current US$) of Japan?
Provide a short and direct response. -4.19e+06. In the year 1992, what is the difference between the Aid flow (current US$) of France and Aid flow (current US$) of Germany?
Offer a terse response. 4.52e+07. In the year 1992, what is the difference between the Aid flow (current US$) in France and Aid flow (current US$) in Italy?
Ensure brevity in your answer.  5.15e+07. In the year 1992, what is the difference between the Aid flow (current US$) in France and Aid flow (current US$) in Japan?
Give a very brief answer. 4.84e+07. In the year 1992, what is the difference between the Aid flow (current US$) of Germany and Aid flow (current US$) of Italy?
Ensure brevity in your answer.  6.30e+06. In the year 1992, what is the difference between the Aid flow (current US$) in Germany and Aid flow (current US$) in Japan?
Offer a very short reply. 3.19e+06. In the year 1992, what is the difference between the Aid flow (current US$) in Italy and Aid flow (current US$) in Japan?
Offer a very short reply. -3.11e+06. In the year 1993, what is the difference between the Aid flow (current US$) of France and Aid flow (current US$) of Germany?
Provide a short and direct response. 1.77e+07. In the year 1993, what is the difference between the Aid flow (current US$) in France and Aid flow (current US$) in Italy?
Offer a terse response. 2.33e+07. In the year 1993, what is the difference between the Aid flow (current US$) of France and Aid flow (current US$) of Japan?
Provide a succinct answer. 2.46e+07. In the year 1993, what is the difference between the Aid flow (current US$) of Germany and Aid flow (current US$) of Italy?
Ensure brevity in your answer.  5.55e+06. In the year 1993, what is the difference between the Aid flow (current US$) of Germany and Aid flow (current US$) of Japan?
Provide a succinct answer. 6.84e+06. In the year 1993, what is the difference between the Aid flow (current US$) of Italy and Aid flow (current US$) of Japan?
Ensure brevity in your answer.  1.29e+06. What is the ratio of the Aid flow (current US$) in France in 1986 to that in 1987?
Ensure brevity in your answer.  0.79. What is the ratio of the Aid flow (current US$) in Germany in 1986 to that in 1987?
Provide a succinct answer. 0.56. What is the ratio of the Aid flow (current US$) in Italy in 1986 to that in 1987?
Provide a succinct answer. 0.73. What is the ratio of the Aid flow (current US$) in Japan in 1986 to that in 1987?
Ensure brevity in your answer.  0.22. What is the ratio of the Aid flow (current US$) in France in 1986 to that in 1988?
Offer a very short reply. 0.86. What is the ratio of the Aid flow (current US$) in Germany in 1986 to that in 1988?
Offer a terse response. 0.44. What is the ratio of the Aid flow (current US$) in Italy in 1986 to that in 1988?
Offer a terse response. 0.53. What is the ratio of the Aid flow (current US$) in Japan in 1986 to that in 1988?
Make the answer very short. 0.56. What is the ratio of the Aid flow (current US$) in France in 1986 to that in 1989?
Give a very brief answer. 0.49. What is the ratio of the Aid flow (current US$) of Germany in 1986 to that in 1989?
Provide a short and direct response. 0.86. What is the ratio of the Aid flow (current US$) in Italy in 1986 to that in 1989?
Provide a short and direct response. 0.47. What is the ratio of the Aid flow (current US$) in Japan in 1986 to that in 1989?
Your answer should be very brief. 0.42. What is the ratio of the Aid flow (current US$) in France in 1986 to that in 1990?
Offer a terse response. 0.33. What is the ratio of the Aid flow (current US$) in Germany in 1986 to that in 1990?
Your answer should be very brief. 0.47. What is the ratio of the Aid flow (current US$) in Italy in 1986 to that in 1990?
Your answer should be very brief. 0.73. What is the ratio of the Aid flow (current US$) of Japan in 1986 to that in 1990?
Your response must be concise. 0.09. What is the ratio of the Aid flow (current US$) in France in 1986 to that in 1991?
Your response must be concise. 0.1. What is the ratio of the Aid flow (current US$) in Germany in 1986 to that in 1991?
Your answer should be compact. 0.32. What is the ratio of the Aid flow (current US$) in Japan in 1986 to that in 1991?
Keep it short and to the point. 0.01. What is the ratio of the Aid flow (current US$) of France in 1986 to that in 1992?
Offer a terse response. 0.09. What is the ratio of the Aid flow (current US$) in Germany in 1986 to that in 1992?
Your response must be concise. 0.31. What is the ratio of the Aid flow (current US$) of Italy in 1986 to that in 1992?
Offer a very short reply. 0.22. What is the ratio of the Aid flow (current US$) of Japan in 1986 to that in 1992?
Your answer should be very brief. 0.01. What is the ratio of the Aid flow (current US$) of France in 1986 to that in 1993?
Your answer should be compact. 0.19. What is the ratio of the Aid flow (current US$) of Germany in 1986 to that in 1993?
Give a very brief answer. 0.28. What is the ratio of the Aid flow (current US$) in Italy in 1986 to that in 1993?
Your answer should be very brief. 0.1. What is the ratio of the Aid flow (current US$) of Japan in 1986 to that in 1993?
Provide a short and direct response. 0.04. What is the ratio of the Aid flow (current US$) of France in 1987 to that in 1988?
Ensure brevity in your answer.  1.09. What is the ratio of the Aid flow (current US$) of Germany in 1987 to that in 1988?
Make the answer very short. 0.78. What is the ratio of the Aid flow (current US$) in Italy in 1987 to that in 1988?
Provide a succinct answer. 0.73. What is the ratio of the Aid flow (current US$) of Japan in 1987 to that in 1988?
Offer a very short reply. 2.56. What is the ratio of the Aid flow (current US$) in France in 1987 to that in 1989?
Offer a terse response. 0.62. What is the ratio of the Aid flow (current US$) of Germany in 1987 to that in 1989?
Offer a very short reply. 1.53. What is the ratio of the Aid flow (current US$) in Italy in 1987 to that in 1989?
Offer a terse response. 0.65. What is the ratio of the Aid flow (current US$) of Japan in 1987 to that in 1989?
Your answer should be compact. 1.92. What is the ratio of the Aid flow (current US$) of France in 1987 to that in 1990?
Make the answer very short. 0.42. What is the ratio of the Aid flow (current US$) in Germany in 1987 to that in 1990?
Provide a succinct answer. 0.84. What is the ratio of the Aid flow (current US$) of Italy in 1987 to that in 1990?
Keep it short and to the point. 1. What is the ratio of the Aid flow (current US$) of Japan in 1987 to that in 1990?
Your answer should be compact. 0.4. What is the ratio of the Aid flow (current US$) of France in 1987 to that in 1991?
Make the answer very short. 0.12. What is the ratio of the Aid flow (current US$) in Germany in 1987 to that in 1991?
Offer a terse response. 0.57. What is the ratio of the Aid flow (current US$) of Italy in 1987 to that in 1991?
Your response must be concise. 6.17. What is the ratio of the Aid flow (current US$) in Japan in 1987 to that in 1991?
Provide a short and direct response. 0.05. What is the ratio of the Aid flow (current US$) in France in 1987 to that in 1992?
Provide a short and direct response. 0.12. What is the ratio of the Aid flow (current US$) of Germany in 1987 to that in 1992?
Offer a very short reply. 0.56. What is the ratio of the Aid flow (current US$) in Italy in 1987 to that in 1992?
Your response must be concise. 0.3. What is the ratio of the Aid flow (current US$) in Japan in 1987 to that in 1992?
Your answer should be compact. 0.05. What is the ratio of the Aid flow (current US$) of France in 1987 to that in 1993?
Provide a succinct answer. 0.24. What is the ratio of the Aid flow (current US$) of Germany in 1987 to that in 1993?
Your answer should be compact. 0.51. What is the ratio of the Aid flow (current US$) in Italy in 1987 to that in 1993?
Offer a terse response. 0.14. What is the ratio of the Aid flow (current US$) in Japan in 1987 to that in 1993?
Offer a very short reply. 0.16. What is the ratio of the Aid flow (current US$) of France in 1988 to that in 1989?
Offer a very short reply. 0.57. What is the ratio of the Aid flow (current US$) in Germany in 1988 to that in 1989?
Offer a very short reply. 1.96. What is the ratio of the Aid flow (current US$) in Italy in 1988 to that in 1989?
Provide a short and direct response. 0.89. What is the ratio of the Aid flow (current US$) of Japan in 1988 to that in 1989?
Provide a short and direct response. 0.75. What is the ratio of the Aid flow (current US$) in France in 1988 to that in 1990?
Your response must be concise. 0.38. What is the ratio of the Aid flow (current US$) in Germany in 1988 to that in 1990?
Offer a terse response. 1.08. What is the ratio of the Aid flow (current US$) in Italy in 1988 to that in 1990?
Provide a succinct answer. 1.38. What is the ratio of the Aid flow (current US$) of Japan in 1988 to that in 1990?
Provide a short and direct response. 0.16. What is the ratio of the Aid flow (current US$) of France in 1988 to that in 1991?
Make the answer very short. 0.11. What is the ratio of the Aid flow (current US$) in Germany in 1988 to that in 1991?
Offer a terse response. 0.72. What is the ratio of the Aid flow (current US$) in Italy in 1988 to that in 1991?
Offer a very short reply. 8.5. What is the ratio of the Aid flow (current US$) of Japan in 1988 to that in 1991?
Your response must be concise. 0.02. What is the ratio of the Aid flow (current US$) in France in 1988 to that in 1992?
Keep it short and to the point. 0.11. What is the ratio of the Aid flow (current US$) of Germany in 1988 to that in 1992?
Your answer should be very brief. 0.71. What is the ratio of the Aid flow (current US$) in Italy in 1988 to that in 1992?
Your answer should be compact. 0.41. What is the ratio of the Aid flow (current US$) of Japan in 1988 to that in 1992?
Ensure brevity in your answer.  0.02. What is the ratio of the Aid flow (current US$) in France in 1988 to that in 1993?
Make the answer very short. 0.22. What is the ratio of the Aid flow (current US$) in Germany in 1988 to that in 1993?
Provide a short and direct response. 0.65. What is the ratio of the Aid flow (current US$) in Italy in 1988 to that in 1993?
Keep it short and to the point. 0.19. What is the ratio of the Aid flow (current US$) of Japan in 1988 to that in 1993?
Give a very brief answer. 0.06. What is the ratio of the Aid flow (current US$) in France in 1989 to that in 1990?
Your answer should be compact. 0.67. What is the ratio of the Aid flow (current US$) of Germany in 1989 to that in 1990?
Your response must be concise. 0.55. What is the ratio of the Aid flow (current US$) of Italy in 1989 to that in 1990?
Offer a very short reply. 1.54. What is the ratio of the Aid flow (current US$) of Japan in 1989 to that in 1990?
Provide a short and direct response. 0.21. What is the ratio of the Aid flow (current US$) of France in 1989 to that in 1991?
Offer a very short reply. 0.2. What is the ratio of the Aid flow (current US$) of Germany in 1989 to that in 1991?
Provide a short and direct response. 0.37. What is the ratio of the Aid flow (current US$) in Italy in 1989 to that in 1991?
Provide a succinct answer. 9.5. What is the ratio of the Aid flow (current US$) in Japan in 1989 to that in 1991?
Your response must be concise. 0.03. What is the ratio of the Aid flow (current US$) in France in 1989 to that in 1992?
Ensure brevity in your answer.  0.19. What is the ratio of the Aid flow (current US$) of Germany in 1989 to that in 1992?
Your response must be concise. 0.36. What is the ratio of the Aid flow (current US$) of Italy in 1989 to that in 1992?
Make the answer very short. 0.46. What is the ratio of the Aid flow (current US$) in Japan in 1989 to that in 1992?
Give a very brief answer. 0.03. What is the ratio of the Aid flow (current US$) of France in 1989 to that in 1993?
Give a very brief answer. 0.39. What is the ratio of the Aid flow (current US$) in Germany in 1989 to that in 1993?
Your response must be concise. 0.33. What is the ratio of the Aid flow (current US$) of Italy in 1989 to that in 1993?
Offer a very short reply. 0.21. What is the ratio of the Aid flow (current US$) in Japan in 1989 to that in 1993?
Provide a short and direct response. 0.08. What is the ratio of the Aid flow (current US$) of France in 1990 to that in 1991?
Provide a short and direct response. 0.29. What is the ratio of the Aid flow (current US$) in Germany in 1990 to that in 1991?
Your answer should be very brief. 0.67. What is the ratio of the Aid flow (current US$) of Italy in 1990 to that in 1991?
Offer a terse response. 6.17. What is the ratio of the Aid flow (current US$) in Japan in 1990 to that in 1991?
Your answer should be compact. 0.13. What is the ratio of the Aid flow (current US$) of France in 1990 to that in 1992?
Your answer should be compact. 0.28. What is the ratio of the Aid flow (current US$) in Germany in 1990 to that in 1992?
Your response must be concise. 0.66. What is the ratio of the Aid flow (current US$) of Italy in 1990 to that in 1992?
Offer a very short reply. 0.3. What is the ratio of the Aid flow (current US$) of Japan in 1990 to that in 1992?
Offer a terse response. 0.13. What is the ratio of the Aid flow (current US$) in France in 1990 to that in 1993?
Provide a short and direct response. 0.58. What is the ratio of the Aid flow (current US$) in Germany in 1990 to that in 1993?
Offer a terse response. 0.6. What is the ratio of the Aid flow (current US$) of Italy in 1990 to that in 1993?
Give a very brief answer. 0.14. What is the ratio of the Aid flow (current US$) of Japan in 1990 to that in 1993?
Your answer should be very brief. 0.4. What is the ratio of the Aid flow (current US$) in France in 1991 to that in 1992?
Your answer should be very brief. 0.97. What is the ratio of the Aid flow (current US$) of Germany in 1991 to that in 1992?
Keep it short and to the point. 0.98. What is the ratio of the Aid flow (current US$) of Italy in 1991 to that in 1992?
Keep it short and to the point. 0.05. What is the ratio of the Aid flow (current US$) of Japan in 1991 to that in 1992?
Offer a very short reply. 0.97. What is the ratio of the Aid flow (current US$) in France in 1991 to that in 1993?
Your answer should be very brief. 1.97. What is the ratio of the Aid flow (current US$) of Germany in 1991 to that in 1993?
Keep it short and to the point. 0.89. What is the ratio of the Aid flow (current US$) in Italy in 1991 to that in 1993?
Make the answer very short. 0.02. What is the ratio of the Aid flow (current US$) of Japan in 1991 to that in 1993?
Your response must be concise. 2.97. What is the ratio of the Aid flow (current US$) of France in 1992 to that in 1993?
Your answer should be very brief. 2.03. What is the ratio of the Aid flow (current US$) of Germany in 1992 to that in 1993?
Provide a short and direct response. 0.91. What is the ratio of the Aid flow (current US$) of Italy in 1992 to that in 1993?
Offer a terse response. 0.46. What is the ratio of the Aid flow (current US$) in Japan in 1992 to that in 1993?
Provide a succinct answer. 3.05. What is the difference between the highest and the second highest Aid flow (current US$) in France?
Make the answer very short. 1.48e+06. What is the difference between the highest and the second highest Aid flow (current US$) in Germany?
Provide a succinct answer. 7.20e+05. What is the difference between the highest and the second highest Aid flow (current US$) of Italy?
Your answer should be compact. 1.47e+06. What is the difference between the highest and the lowest Aid flow (current US$) of France?
Keep it short and to the point. 4.78e+07. What is the difference between the highest and the lowest Aid flow (current US$) in Germany?
Keep it short and to the point. 5.92e+06. What is the difference between the highest and the lowest Aid flow (current US$) of Italy?
Give a very brief answer. 2.66e+06. What is the difference between the highest and the lowest Aid flow (current US$) of Japan?
Keep it short and to the point. 4.31e+06. 